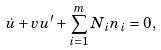<formula> <loc_0><loc_0><loc_500><loc_500>\dot { u } + v u ^ { \prime } + \sum _ { i = 1 } ^ { m } N _ { i } n _ { i } = 0 ,</formula> 